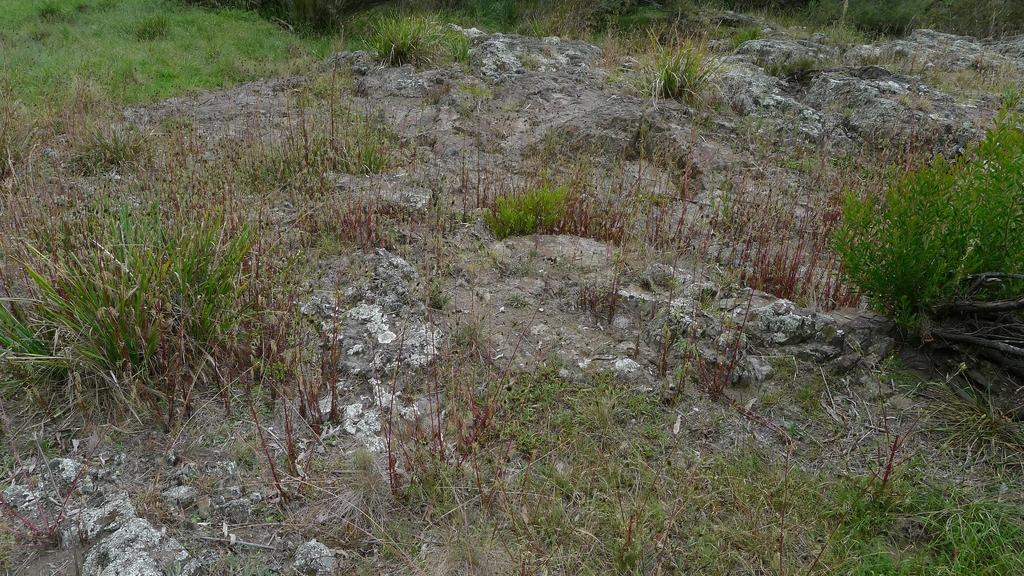What type of vegetation is present on the ground in the image? There are many grasses on the ground in the image. What other natural elements can be seen in the image? There are many rocks visible in the image. How much money is being exchanged in the image? There is no money being exchanged in the image; it features grasses and rocks. What thoughts or ideas are being expressed in the image? The image does not depict any thoughts or ideas; it is a visual representation of grasses and rocks. 